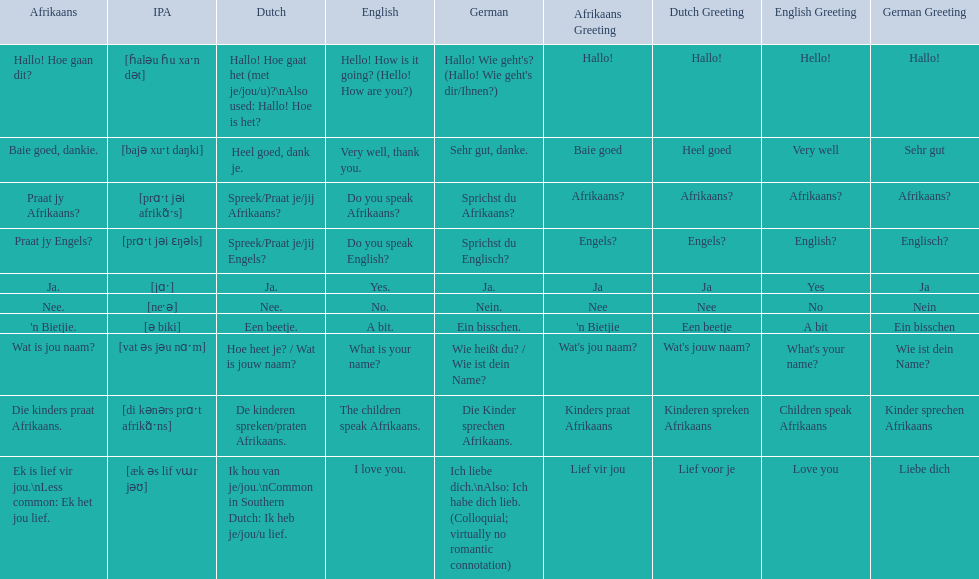In german how do you say do you speak afrikaans? Sprichst du Afrikaans?. How do you say it in afrikaans? Praat jy Afrikaans?. 